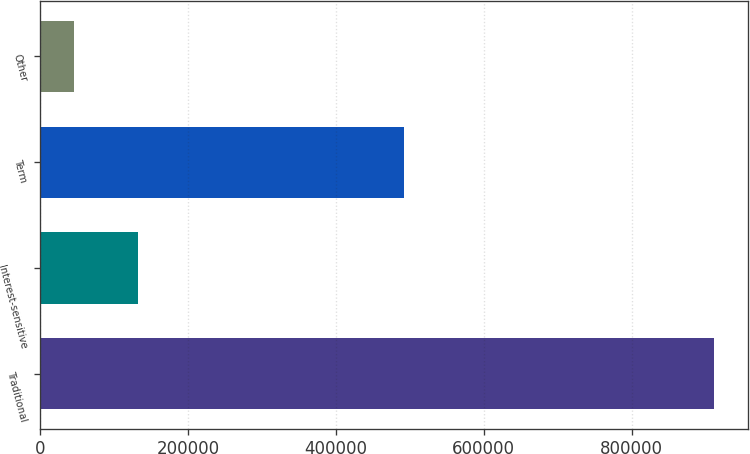Convert chart to OTSL. <chart><loc_0><loc_0><loc_500><loc_500><bar_chart><fcel>Traditional<fcel>Interest-sensitive<fcel>Term<fcel>Other<nl><fcel>911444<fcel>131980<fcel>492409<fcel>45373<nl></chart> 